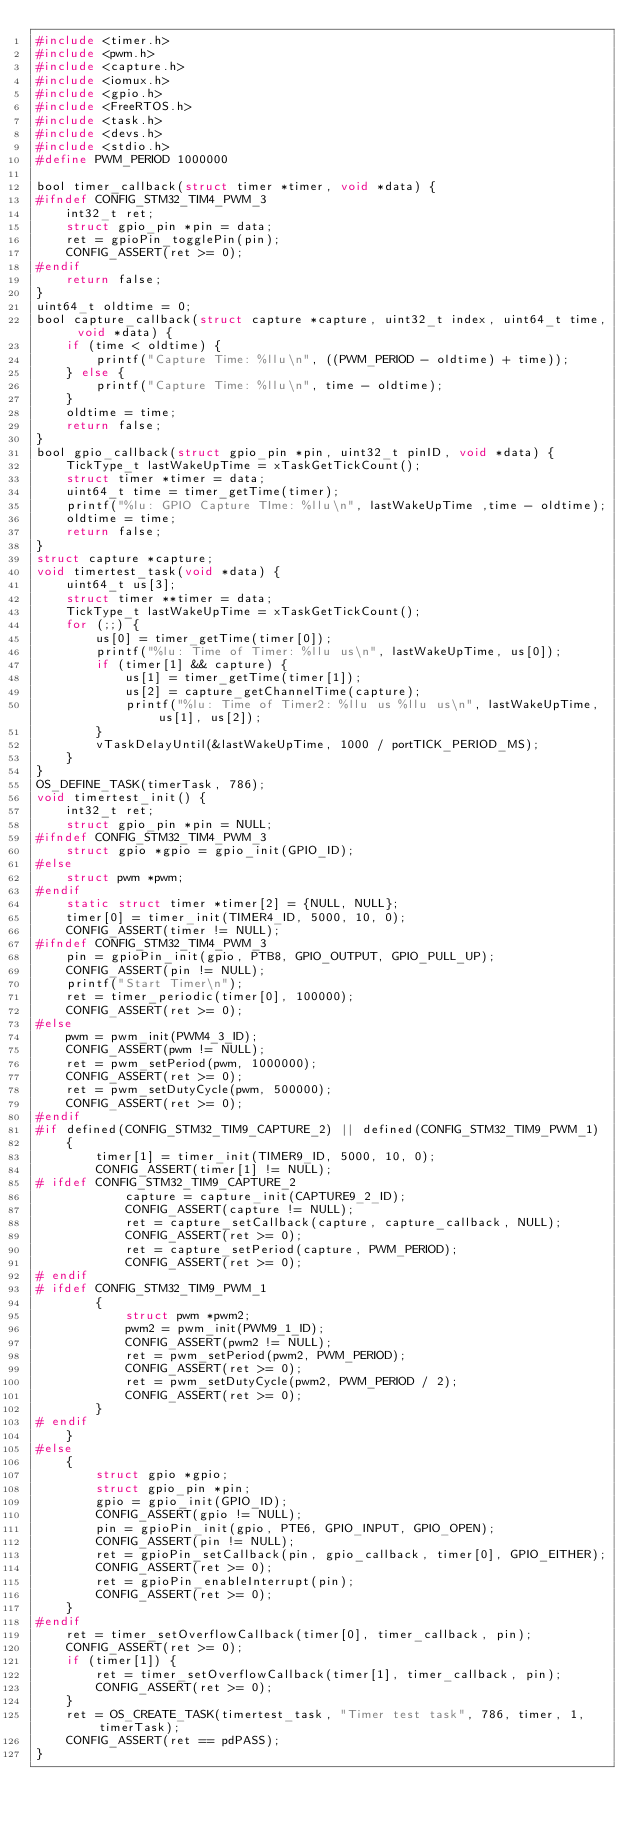<code> <loc_0><loc_0><loc_500><loc_500><_C_>#include <timer.h>
#include <pwm.h>
#include <capture.h>
#include <iomux.h>
#include <gpio.h>
#include <FreeRTOS.h>
#include <task.h>
#include <devs.h>
#include <stdio.h>
#define PWM_PERIOD 1000000

bool timer_callback(struct timer *timer, void *data) {
#ifndef CONFIG_STM32_TIM4_PWM_3
	int32_t ret;
	struct gpio_pin *pin = data;
	ret = gpioPin_togglePin(pin);
	CONFIG_ASSERT(ret >= 0);
#endif
	return false;
}
uint64_t oldtime = 0;
bool capture_callback(struct capture *capture, uint32_t index, uint64_t time, void *data) {
	if (time < oldtime) {
		printf("Capture Time: %llu\n", ((PWM_PERIOD - oldtime) + time));
	} else {
		printf("Capture Time: %llu\n", time - oldtime);
	}
	oldtime = time;
	return false;
}
bool gpio_callback(struct gpio_pin *pin, uint32_t pinID, void *data) {
	TickType_t lastWakeUpTime = xTaskGetTickCount();
	struct timer *timer = data;
	uint64_t time = timer_getTime(timer);
	printf("%lu: GPIO Capture TIme: %llu\n", lastWakeUpTime ,time - oldtime);
	oldtime = time;
	return false;
}
struct capture *capture;
void timertest_task(void *data) {
	uint64_t us[3];
	struct timer **timer = data;
	TickType_t lastWakeUpTime = xTaskGetTickCount();
	for (;;) {
		us[0] = timer_getTime(timer[0]);
		printf("%lu: Time of Timer: %llu us\n", lastWakeUpTime, us[0]);
		if (timer[1] && capture) {
			us[1] = timer_getTime(timer[1]);
			us[2] = capture_getChannelTime(capture);
			printf("%lu: Time of Timer2: %llu us %llu us\n", lastWakeUpTime, us[1], us[2]);
		}
		vTaskDelayUntil(&lastWakeUpTime, 1000 / portTICK_PERIOD_MS);
	}
}
OS_DEFINE_TASK(timerTask, 786);
void timertest_init() {
	int32_t ret;
	struct gpio_pin *pin = NULL;
#ifndef CONFIG_STM32_TIM4_PWM_3
	struct gpio *gpio = gpio_init(GPIO_ID);
#else
	struct pwm *pwm;
#endif
	static struct timer *timer[2] = {NULL, NULL};
	timer[0] = timer_init(TIMER4_ID, 5000, 10, 0);
	CONFIG_ASSERT(timer != NULL);
#ifndef CONFIG_STM32_TIM4_PWM_3
	pin = gpioPin_init(gpio, PTB8, GPIO_OUTPUT, GPIO_PULL_UP);
	CONFIG_ASSERT(pin != NULL);
	printf("Start Timer\n");
	ret = timer_periodic(timer[0], 100000);
	CONFIG_ASSERT(ret >= 0);
#else
	pwm = pwm_init(PWM4_3_ID);
	CONFIG_ASSERT(pwm != NULL);
	ret = pwm_setPeriod(pwm, 1000000);
	CONFIG_ASSERT(ret >= 0);
	ret = pwm_setDutyCycle(pwm, 500000);
	CONFIG_ASSERT(ret >= 0);
#endif
#if defined(CONFIG_STM32_TIM9_CAPTURE_2) || defined(CONFIG_STM32_TIM9_PWM_1)
	{
		timer[1] = timer_init(TIMER9_ID, 5000, 10, 0);
		CONFIG_ASSERT(timer[1] != NULL);
# ifdef CONFIG_STM32_TIM9_CAPTURE_2
			capture = capture_init(CAPTURE9_2_ID);
			CONFIG_ASSERT(capture != NULL);
			ret = capture_setCallback(capture, capture_callback, NULL);
			CONFIG_ASSERT(ret >= 0);
			ret = capture_setPeriod(capture, PWM_PERIOD);
			CONFIG_ASSERT(ret >= 0);
# endif
# ifdef CONFIG_STM32_TIM9_PWM_1
		{
			struct pwm *pwm2;
			pwm2 = pwm_init(PWM9_1_ID);
			CONFIG_ASSERT(pwm2 != NULL);
			ret = pwm_setPeriod(pwm2, PWM_PERIOD);
			CONFIG_ASSERT(ret >= 0);
			ret = pwm_setDutyCycle(pwm2, PWM_PERIOD / 2);
			CONFIG_ASSERT(ret >= 0);
		}
# endif
	}
#else
	{
		struct gpio *gpio;
		struct gpio_pin *pin;
		gpio = gpio_init(GPIO_ID);
		CONFIG_ASSERT(gpio != NULL);
		pin = gpioPin_init(gpio, PTE6, GPIO_INPUT, GPIO_OPEN);
		CONFIG_ASSERT(pin != NULL);
		ret = gpioPin_setCallback(pin, gpio_callback, timer[0], GPIO_EITHER);
		CONFIG_ASSERT(ret >= 0);
		ret = gpioPin_enableInterrupt(pin);
		CONFIG_ASSERT(ret >= 0);
	}
#endif
	ret = timer_setOverflowCallback(timer[0], timer_callback, pin);
	CONFIG_ASSERT(ret >= 0);
	if (timer[1]) {
		ret = timer_setOverflowCallback(timer[1], timer_callback, pin);
		CONFIG_ASSERT(ret >= 0);
	}
	ret = OS_CREATE_TASK(timertest_task, "Timer test task", 786, timer, 1, timerTask);
	CONFIG_ASSERT(ret == pdPASS);
}
</code> 